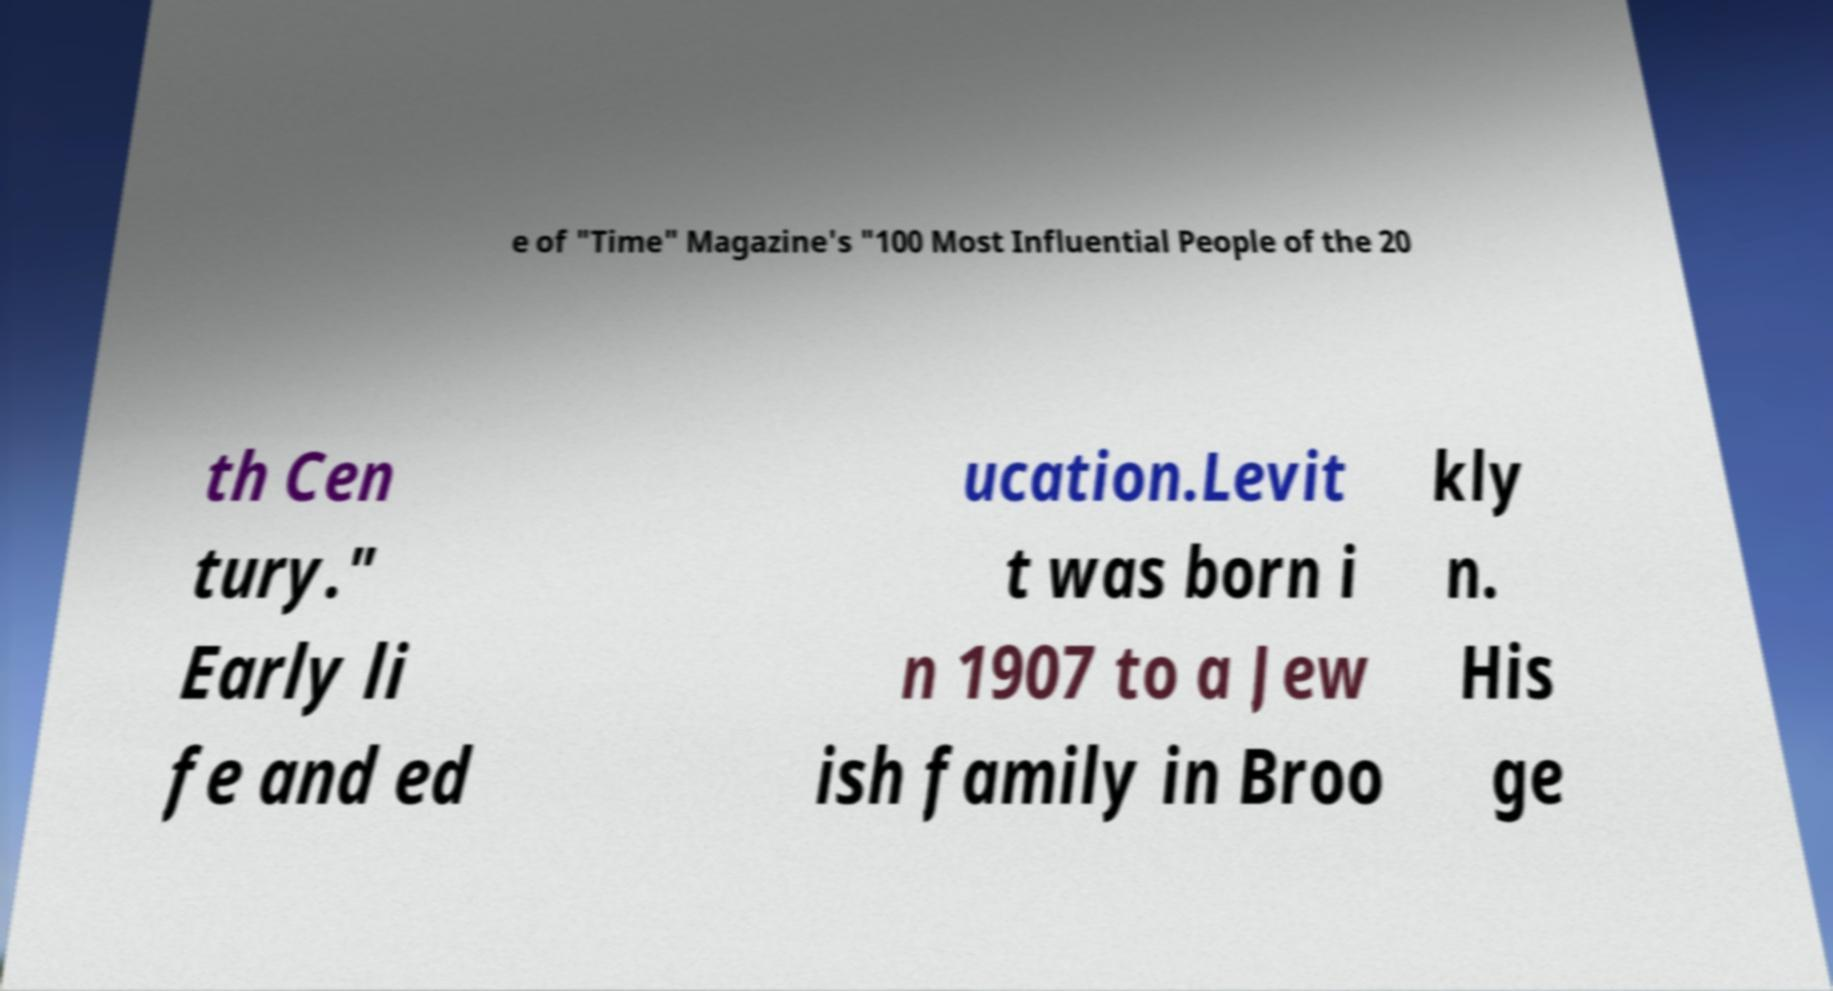For documentation purposes, I need the text within this image transcribed. Could you provide that? e of "Time" Magazine's "100 Most Influential People of the 20 th Cen tury." Early li fe and ed ucation.Levit t was born i n 1907 to a Jew ish family in Broo kly n. His ge 